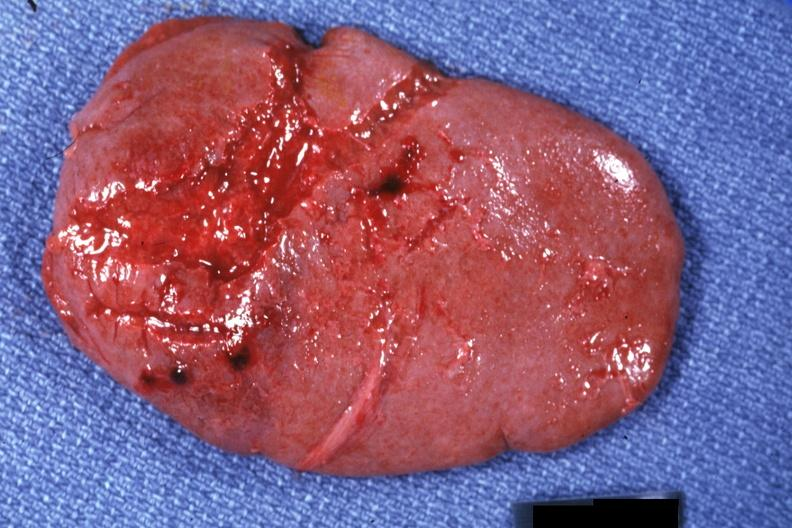s spleen present?
Answer the question using a single word or phrase. Yes 